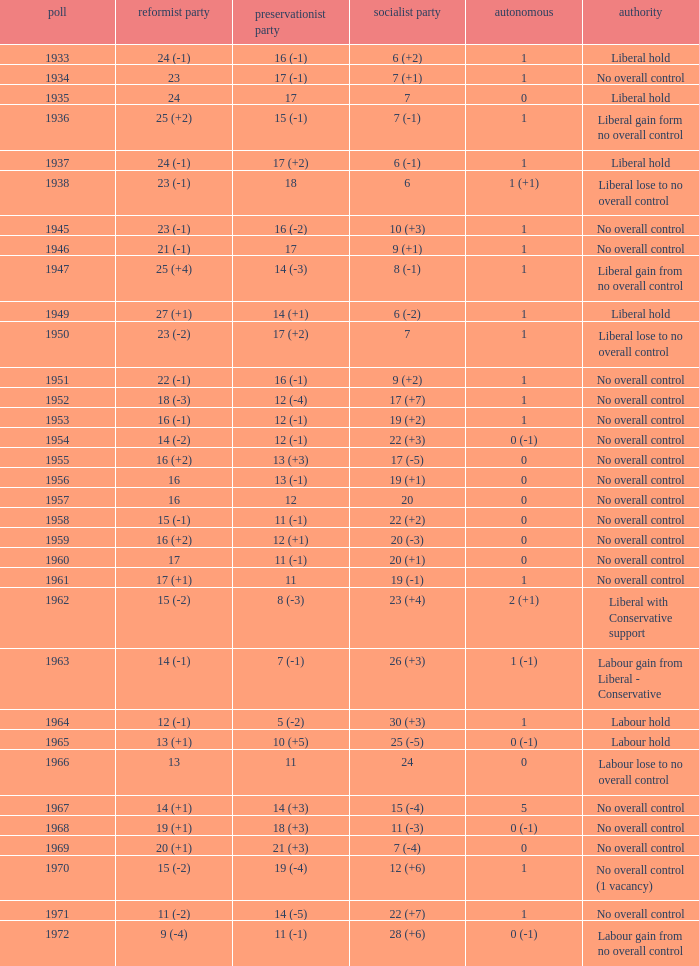What was the control for the year with a conservative party achievement of 10 (+5)? Labour hold. 